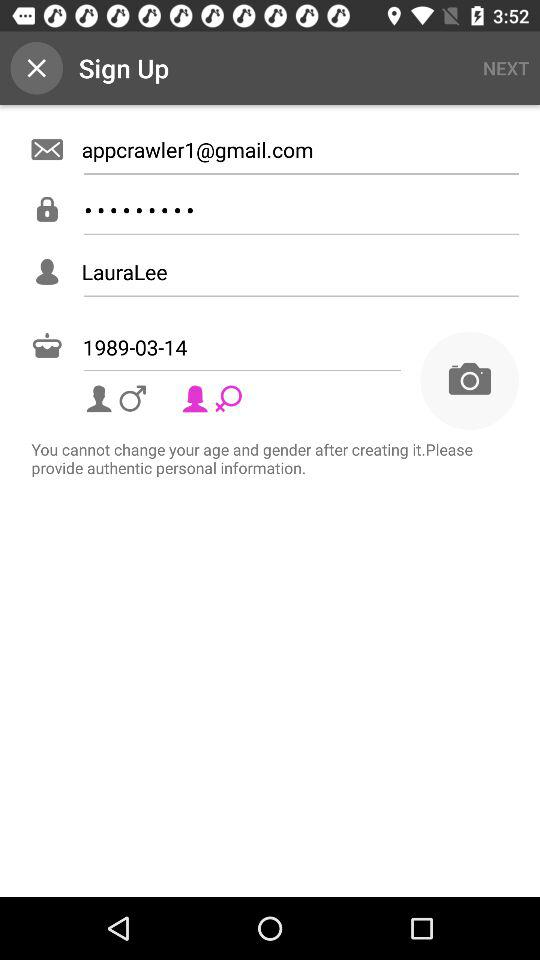What is the email address? The email address is appcrawler1@gmail.com. 